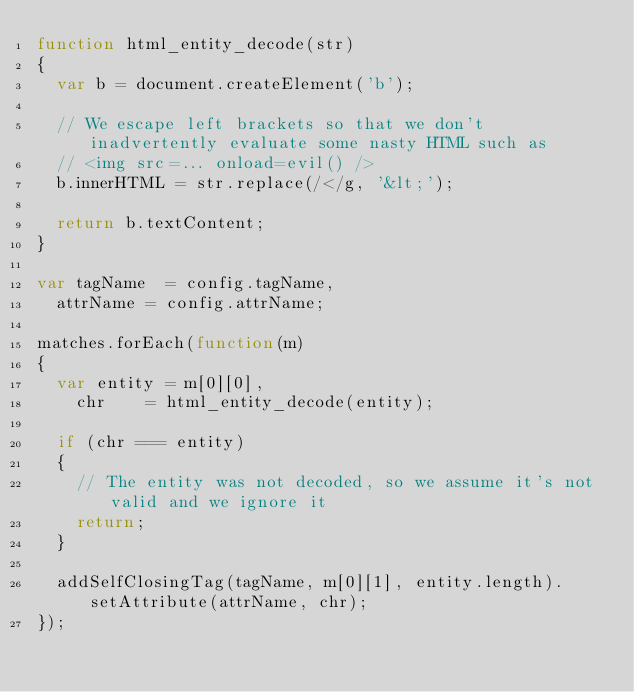Convert code to text. <code><loc_0><loc_0><loc_500><loc_500><_JavaScript_>function html_entity_decode(str)
{
	var b = document.createElement('b');

	// We escape left brackets so that we don't inadvertently evaluate some nasty HTML such as
	// <img src=... onload=evil() />
	b.innerHTML = str.replace(/</g, '&lt;');

	return b.textContent;
}
	
var tagName  = config.tagName,
	attrName = config.attrName;

matches.forEach(function(m)
{
	var entity = m[0][0],
		chr    = html_entity_decode(entity);

	if (chr === entity)
	{
		// The entity was not decoded, so we assume it's not valid and we ignore it
		return;
	}

	addSelfClosingTag(tagName, m[0][1], entity.length).setAttribute(attrName, chr);
});</code> 